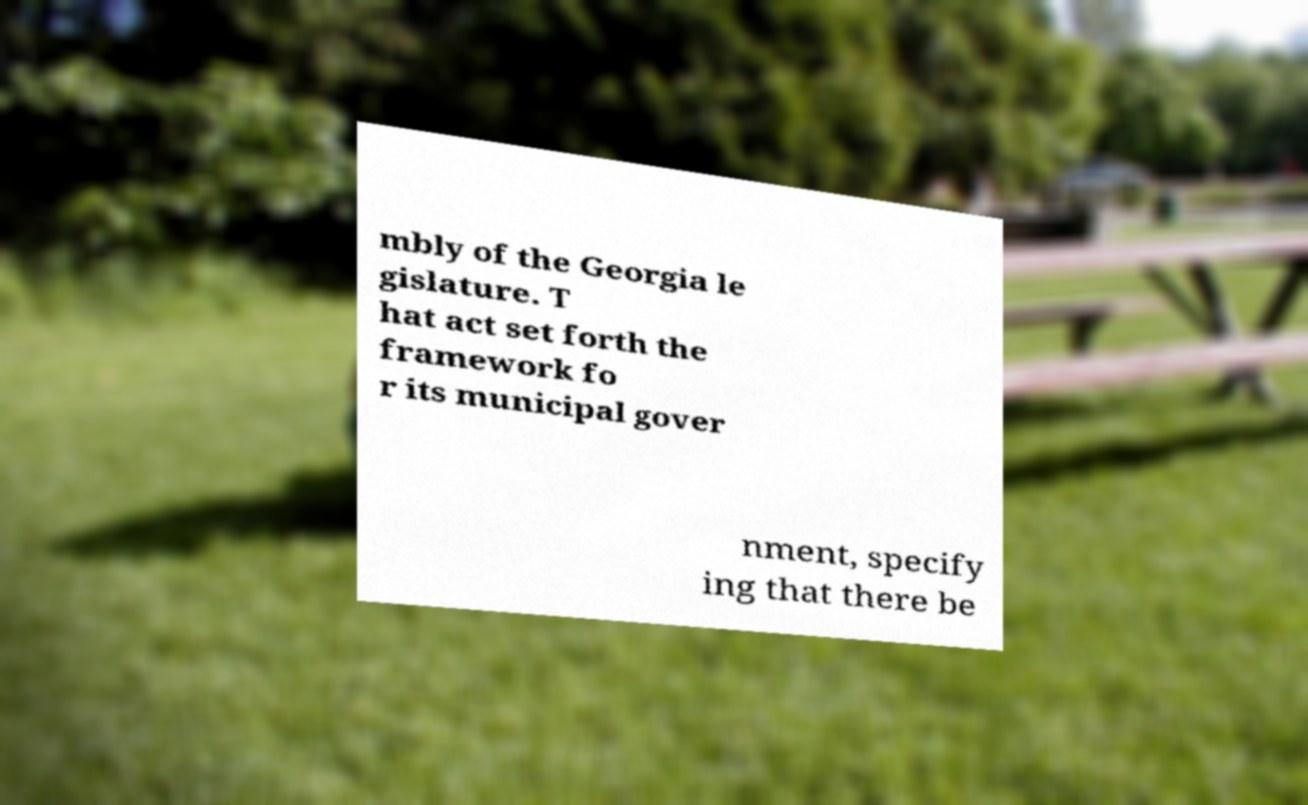I need the written content from this picture converted into text. Can you do that? mbly of the Georgia le gislature. T hat act set forth the framework fo r its municipal gover nment, specify ing that there be 